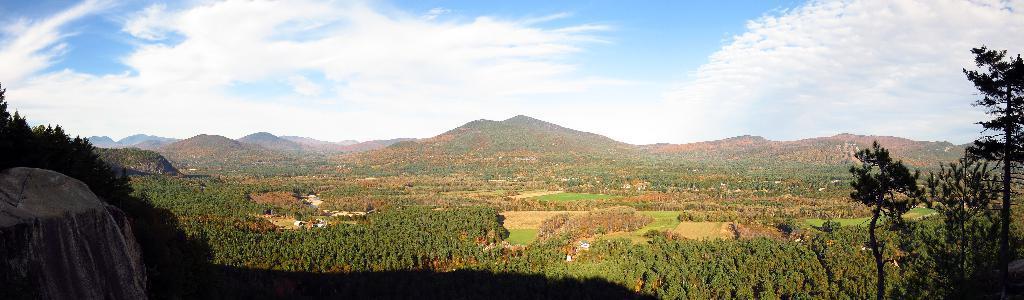Could you give a brief overview of what you see in this image? Sky is cloudy. Far there are mountains and number of trees. 